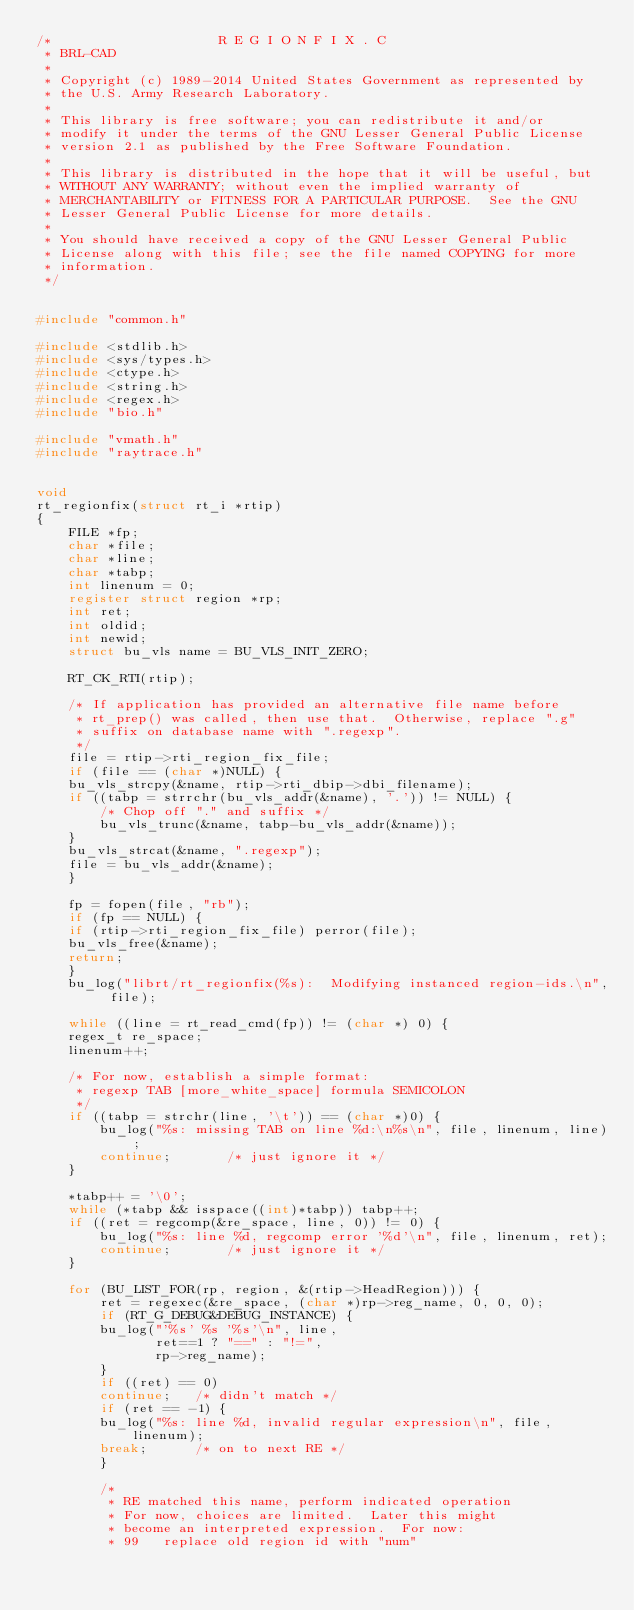Convert code to text. <code><loc_0><loc_0><loc_500><loc_500><_C_>/*                     R E G I O N F I X . C
 * BRL-CAD
 *
 * Copyright (c) 1989-2014 United States Government as represented by
 * the U.S. Army Research Laboratory.
 *
 * This library is free software; you can redistribute it and/or
 * modify it under the terms of the GNU Lesser General Public License
 * version 2.1 as published by the Free Software Foundation.
 *
 * This library is distributed in the hope that it will be useful, but
 * WITHOUT ANY WARRANTY; without even the implied warranty of
 * MERCHANTABILITY or FITNESS FOR A PARTICULAR PURPOSE.  See the GNU
 * Lesser General Public License for more details.
 *
 * You should have received a copy of the GNU Lesser General Public
 * License along with this file; see the file named COPYING for more
 * information.
 */


#include "common.h"

#include <stdlib.h>
#include <sys/types.h>
#include <ctype.h>
#include <string.h>
#include <regex.h>
#include "bio.h"

#include "vmath.h"
#include "raytrace.h"


void
rt_regionfix(struct rt_i *rtip)
{
    FILE *fp;
    char *file;
    char *line;
    char *tabp;
    int linenum = 0;
    register struct region *rp;
    int ret;
    int oldid;
    int newid;
    struct bu_vls name = BU_VLS_INIT_ZERO;

    RT_CK_RTI(rtip);

    /* If application has provided an alternative file name before
     * rt_prep() was called, then use that.  Otherwise, replace ".g"
     * suffix on database name with ".regexp".
     */
    file = rtip->rti_region_fix_file;
    if (file == (char *)NULL) {
	bu_vls_strcpy(&name, rtip->rti_dbip->dbi_filename);
	if ((tabp = strrchr(bu_vls_addr(&name), '.')) != NULL) {
	    /* Chop off "." and suffix */
	    bu_vls_trunc(&name, tabp-bu_vls_addr(&name));
	}
	bu_vls_strcat(&name, ".regexp");
	file = bu_vls_addr(&name);
    }

    fp = fopen(file, "rb");
    if (fp == NULL) {
	if (rtip->rti_region_fix_file) perror(file);
	bu_vls_free(&name);
	return;
    }
    bu_log("librt/rt_regionfix(%s):  Modifying instanced region-ids.\n", file);

    while ((line = rt_read_cmd(fp)) != (char *) 0) {
	regex_t re_space;
	linenum++;

	/* For now, establish a simple format:
	 * regexp TAB [more_white_space] formula SEMICOLON
	 */
	if ((tabp = strchr(line, '\t')) == (char *)0) {
	    bu_log("%s: missing TAB on line %d:\n%s\n", file, linenum, line);
	    continue;		/* just ignore it */
	}

	*tabp++ = '\0';
	while (*tabp && isspace((int)*tabp)) tabp++;
	if ((ret = regcomp(&re_space, line, 0)) != 0) {
	    bu_log("%s: line %d, regcomp error '%d'\n", file, linenum, ret);
	    continue;		/* just ignore it */
	}

	for (BU_LIST_FOR(rp, region, &(rtip->HeadRegion))) {
	    ret = regexec(&re_space, (char *)rp->reg_name, 0, 0, 0);
	    if (RT_G_DEBUG&DEBUG_INSTANCE) {
		bu_log("'%s' %s '%s'\n", line,
		       ret==1 ? "==" : "!=",
		       rp->reg_name);
	    }
	    if ((ret) == 0)
		continue;	/* didn't match */
	    if (ret == -1) {
		bu_log("%s: line %d, invalid regular expression\n", file, linenum);
		break;		/* on to next RE */
	    }

	    /*
	     * RE matched this name, perform indicated operation
	     * For now, choices are limited.  Later this might
	     * become an interpreted expression.  For now:
	     * 99	replace old region id with "num"</code> 